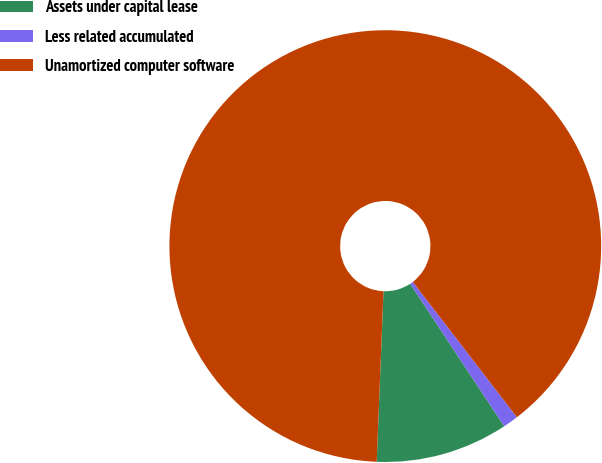<chart> <loc_0><loc_0><loc_500><loc_500><pie_chart><fcel>Assets under capital lease<fcel>Less related accumulated<fcel>Unamortized computer software<nl><fcel>9.92%<fcel>1.15%<fcel>88.93%<nl></chart> 